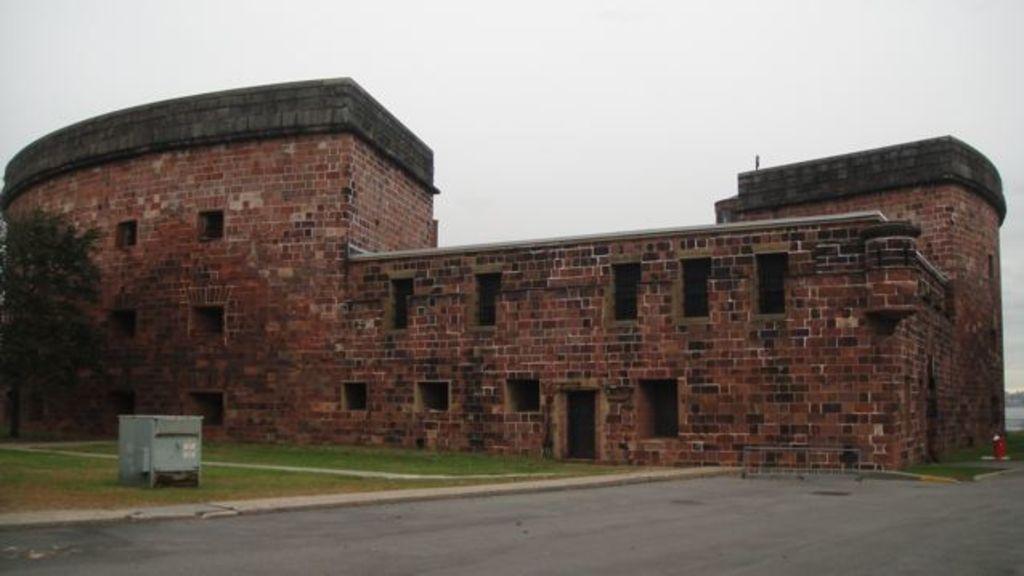Please provide a concise description of this image. In this picture we can see the road, grass, tree, building and some objects and in the background we can see the sky. 